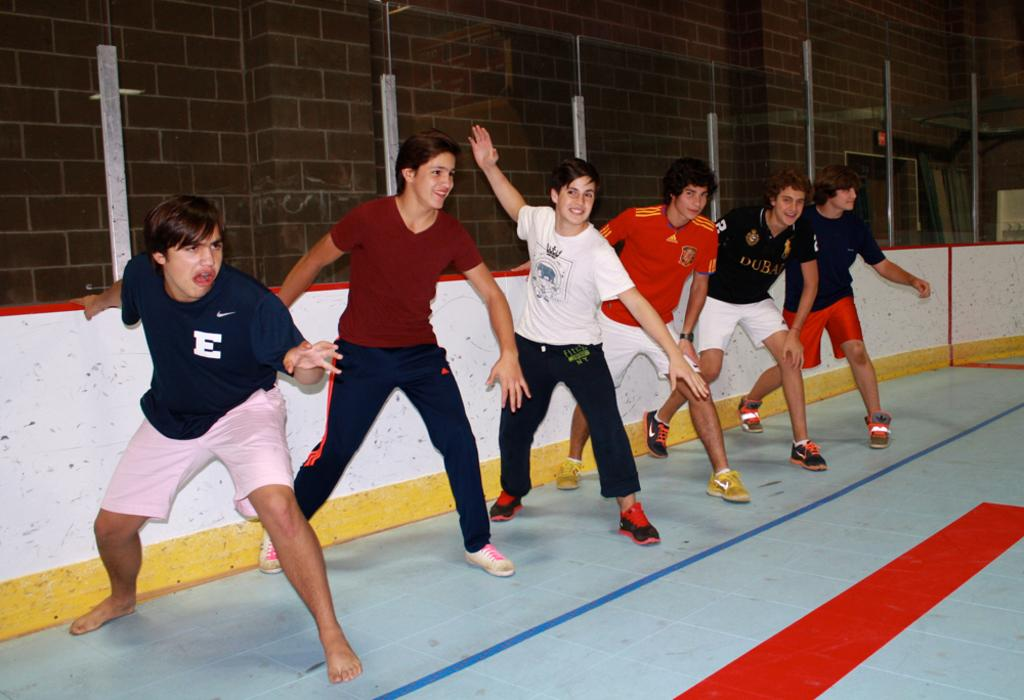How many people are in the image? There is a group of people in the image, but the exact number is not specified. What can be said about the floor in the image? The floor has tiles. What type of kite is being flown by the people in the image? There is no kite present in the image; it only shows a group of people and a tiled floor. What color is the flag that the people are holding in the image? There is no flag present in the image; it only shows a group of people and a tiled floor. 